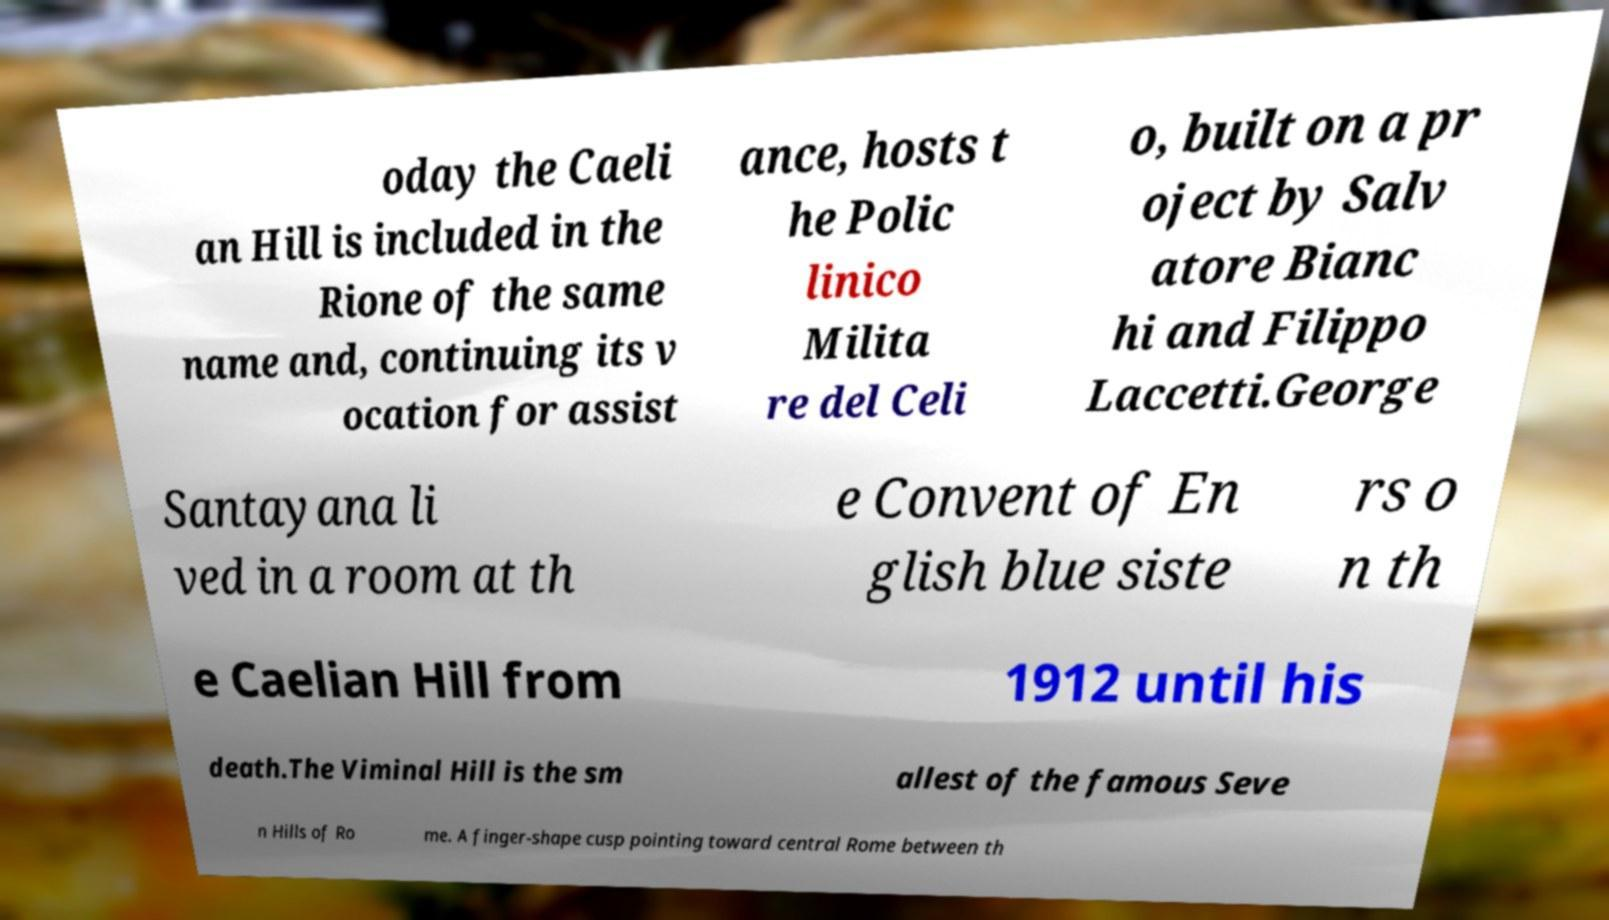Can you accurately transcribe the text from the provided image for me? oday the Caeli an Hill is included in the Rione of the same name and, continuing its v ocation for assist ance, hosts t he Polic linico Milita re del Celi o, built on a pr oject by Salv atore Bianc hi and Filippo Laccetti.George Santayana li ved in a room at th e Convent of En glish blue siste rs o n th e Caelian Hill from 1912 until his death.The Viminal Hill is the sm allest of the famous Seve n Hills of Ro me. A finger-shape cusp pointing toward central Rome between th 